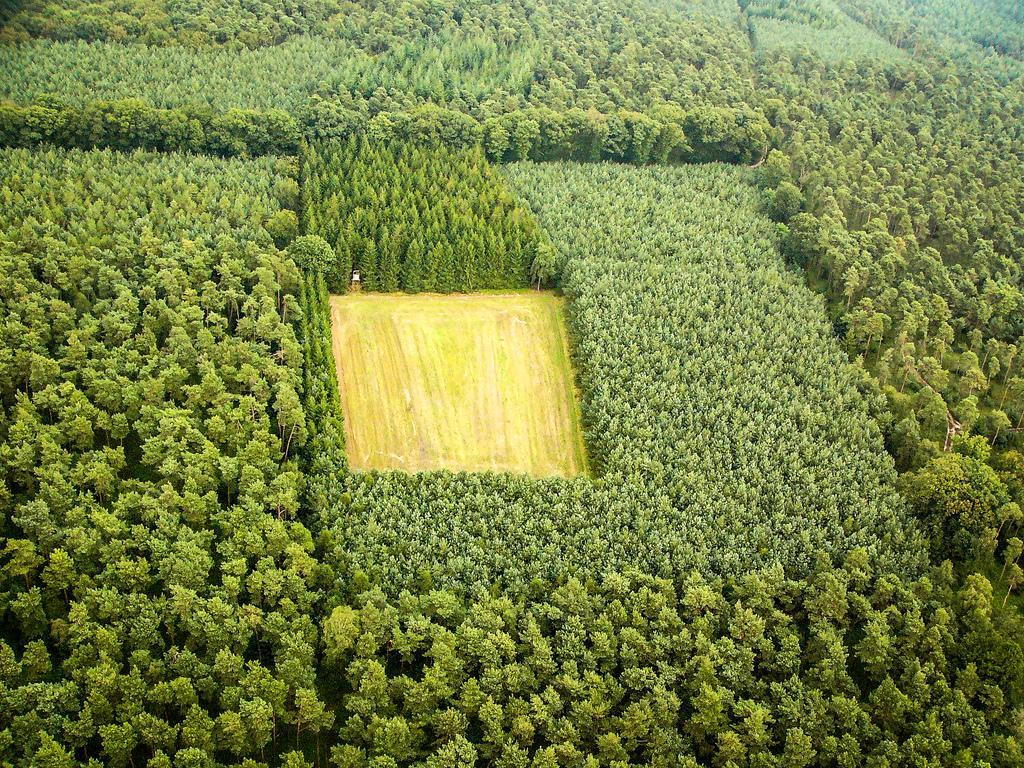Can you describe this image briefly? In this image I can see few green color trees and the ground. 